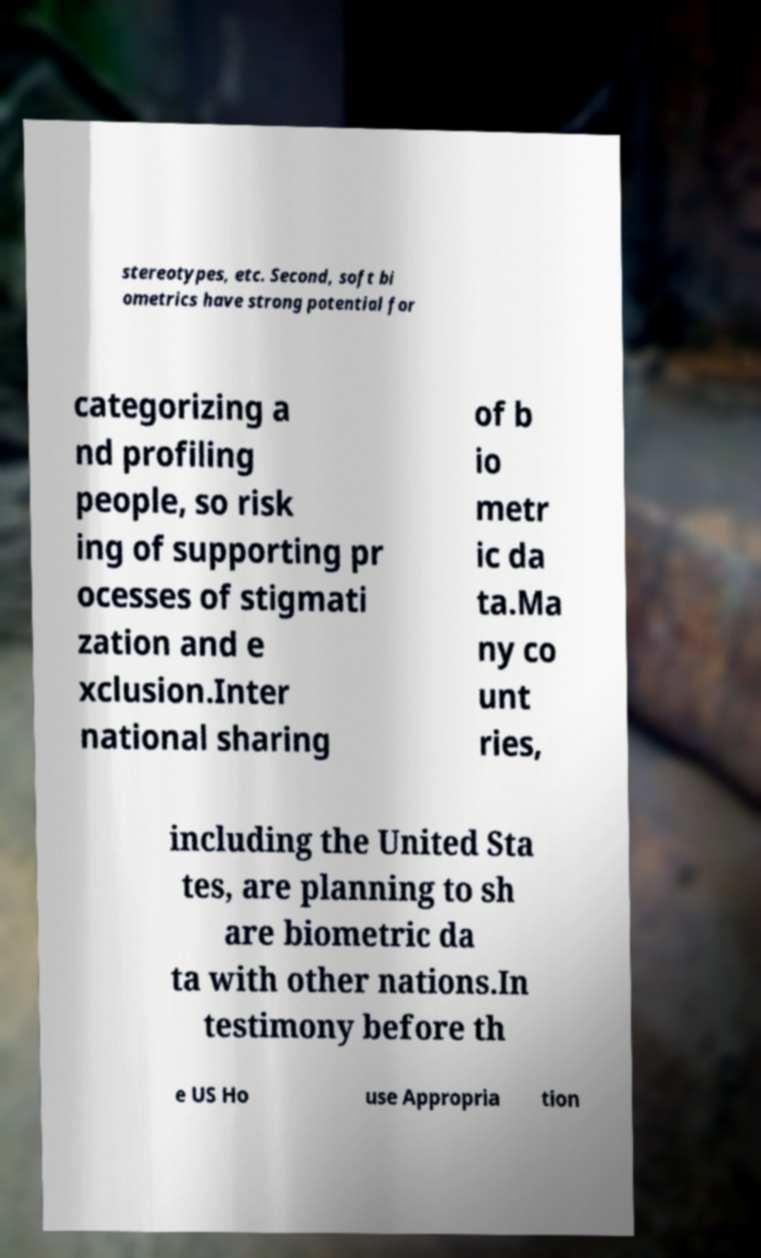Could you extract and type out the text from this image? stereotypes, etc. Second, soft bi ometrics have strong potential for categorizing a nd profiling people, so risk ing of supporting pr ocesses of stigmati zation and e xclusion.Inter national sharing of b io metr ic da ta.Ma ny co unt ries, including the United Sta tes, are planning to sh are biometric da ta with other nations.In testimony before th e US Ho use Appropria tion 